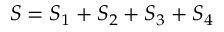Convert formula to latex. <formula><loc_0><loc_0><loc_500><loc_500>S = S _ { 1 } + S _ { 2 } + S _ { 3 } + S _ { 4 }</formula> 